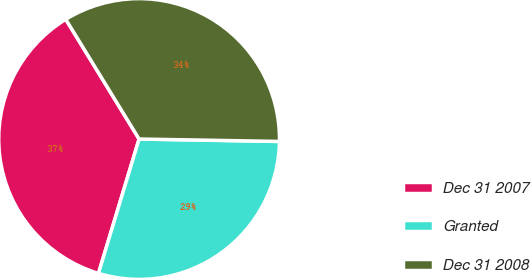Convert chart to OTSL. <chart><loc_0><loc_0><loc_500><loc_500><pie_chart><fcel>Dec 31 2007<fcel>Granted<fcel>Dec 31 2008<nl><fcel>36.58%<fcel>29.4%<fcel>34.02%<nl></chart> 